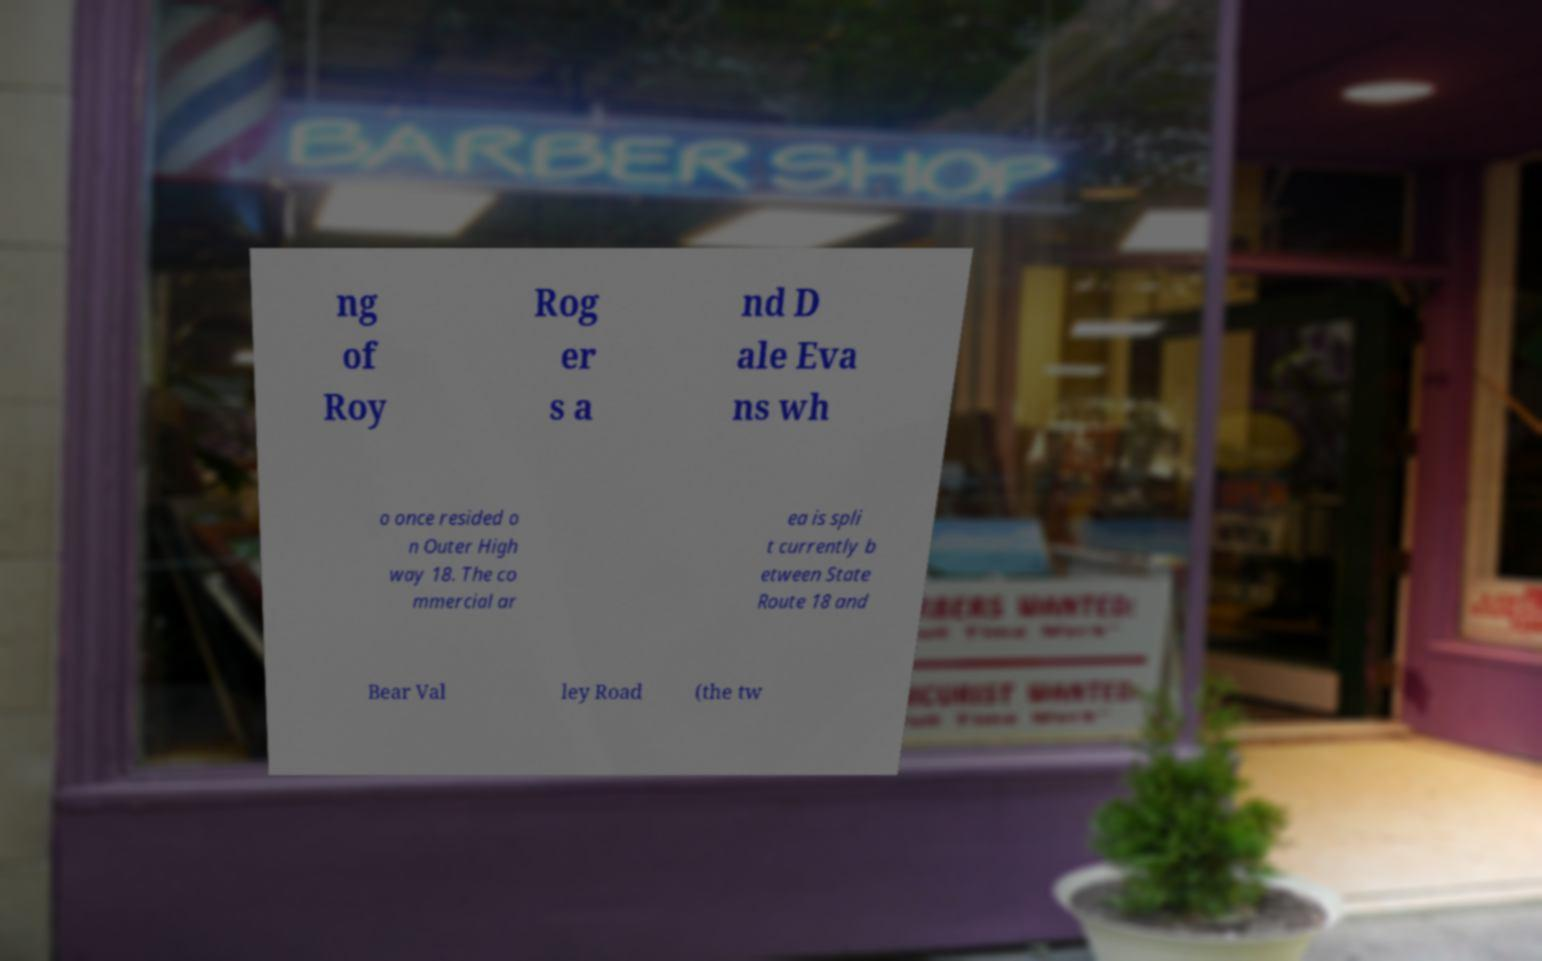What messages or text are displayed in this image? I need them in a readable, typed format. ng of Roy Rog er s a nd D ale Eva ns wh o once resided o n Outer High way 18. The co mmercial ar ea is spli t currently b etween State Route 18 and Bear Val ley Road (the tw 